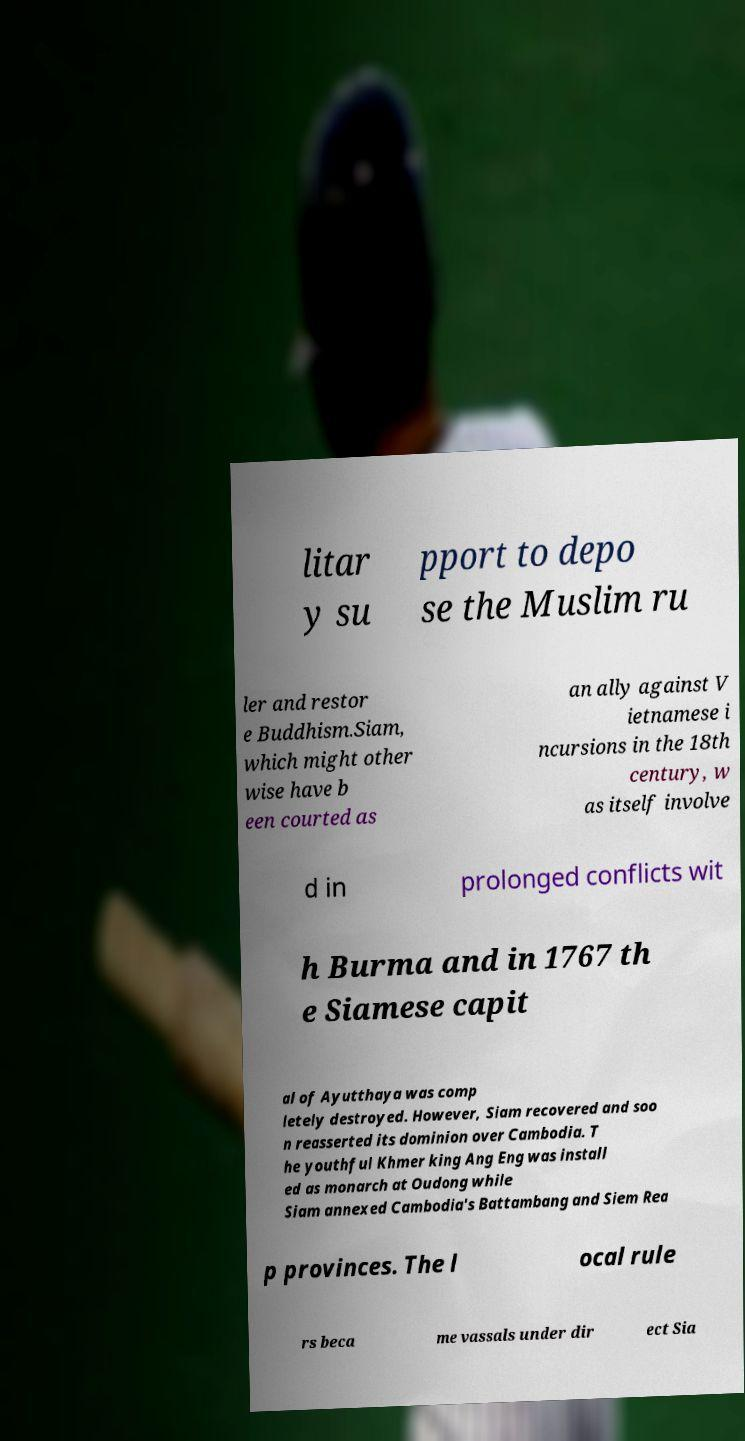Please identify and transcribe the text found in this image. litar y su pport to depo se the Muslim ru ler and restor e Buddhism.Siam, which might other wise have b een courted as an ally against V ietnamese i ncursions in the 18th century, w as itself involve d in prolonged conflicts wit h Burma and in 1767 th e Siamese capit al of Ayutthaya was comp letely destroyed. However, Siam recovered and soo n reasserted its dominion over Cambodia. T he youthful Khmer king Ang Eng was install ed as monarch at Oudong while Siam annexed Cambodia's Battambang and Siem Rea p provinces. The l ocal rule rs beca me vassals under dir ect Sia 